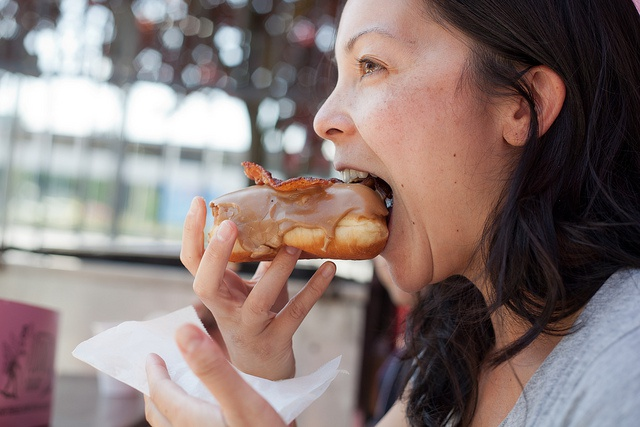Describe the objects in this image and their specific colors. I can see people in lightgray, black, brown, tan, and darkgray tones and donut in lightgray, salmon, brown, darkgray, and tan tones in this image. 